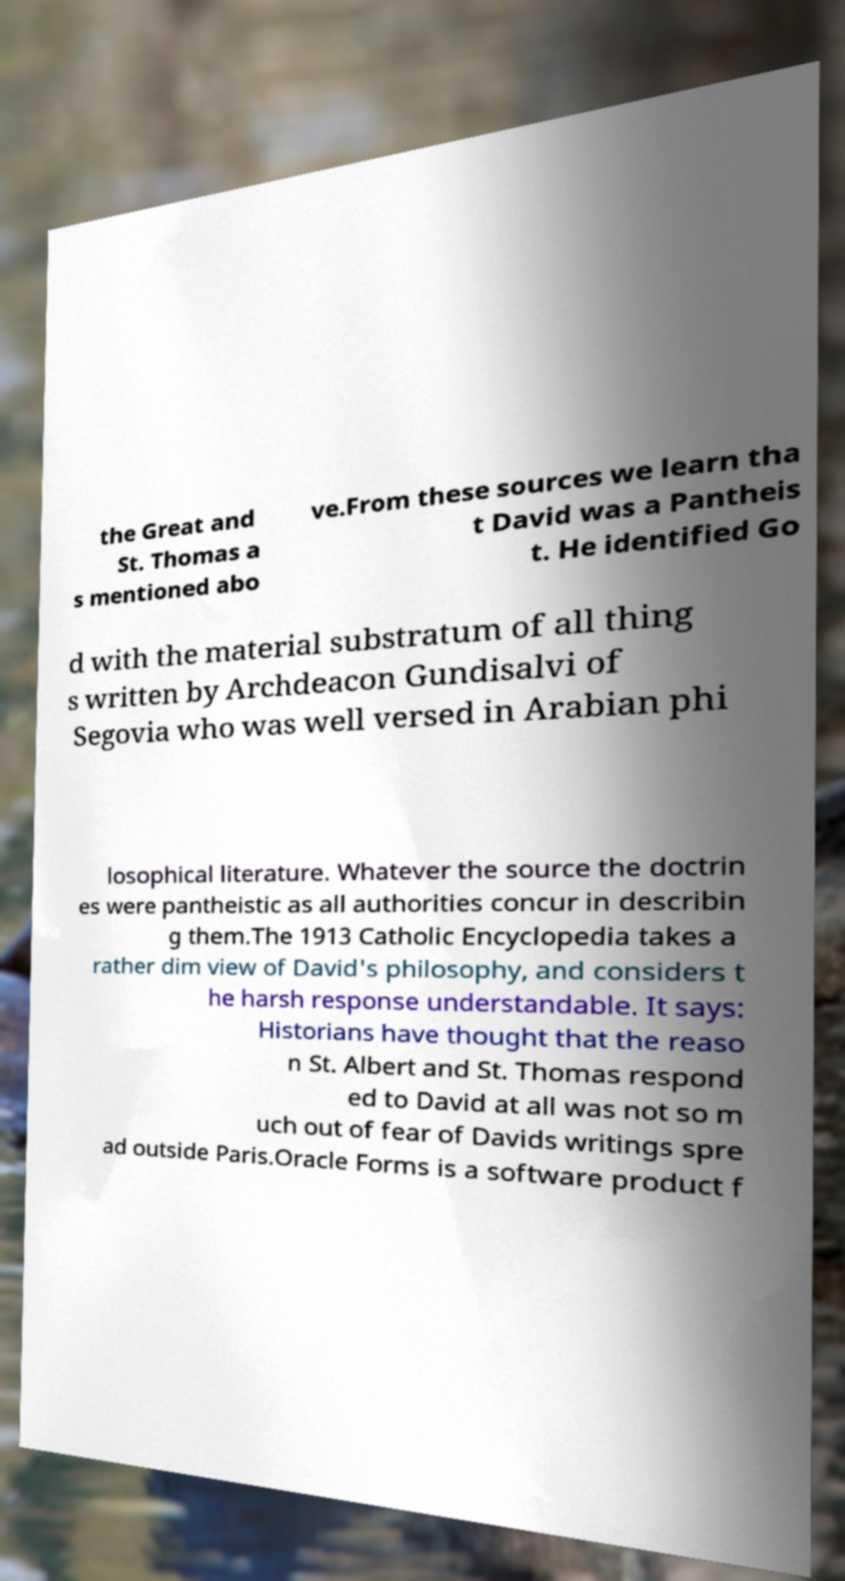I need the written content from this picture converted into text. Can you do that? the Great and St. Thomas a s mentioned abo ve.From these sources we learn tha t David was a Pantheis t. He identified Go d with the material substratum of all thing s written by Archdeacon Gundisalvi of Segovia who was well versed in Arabian phi losophical literature. Whatever the source the doctrin es were pantheistic as all authorities concur in describin g them.The 1913 Catholic Encyclopedia takes a rather dim view of David's philosophy, and considers t he harsh response understandable. It says: Historians have thought that the reaso n St. Albert and St. Thomas respond ed to David at all was not so m uch out of fear of Davids writings spre ad outside Paris.Oracle Forms is a software product f 